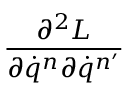Convert formula to latex. <formula><loc_0><loc_0><loc_500><loc_500>\frac { \partial ^ { 2 } L } { \partial \dot { q } ^ { n } \partial \dot { q } ^ { n ^ { \prime } } }</formula> 